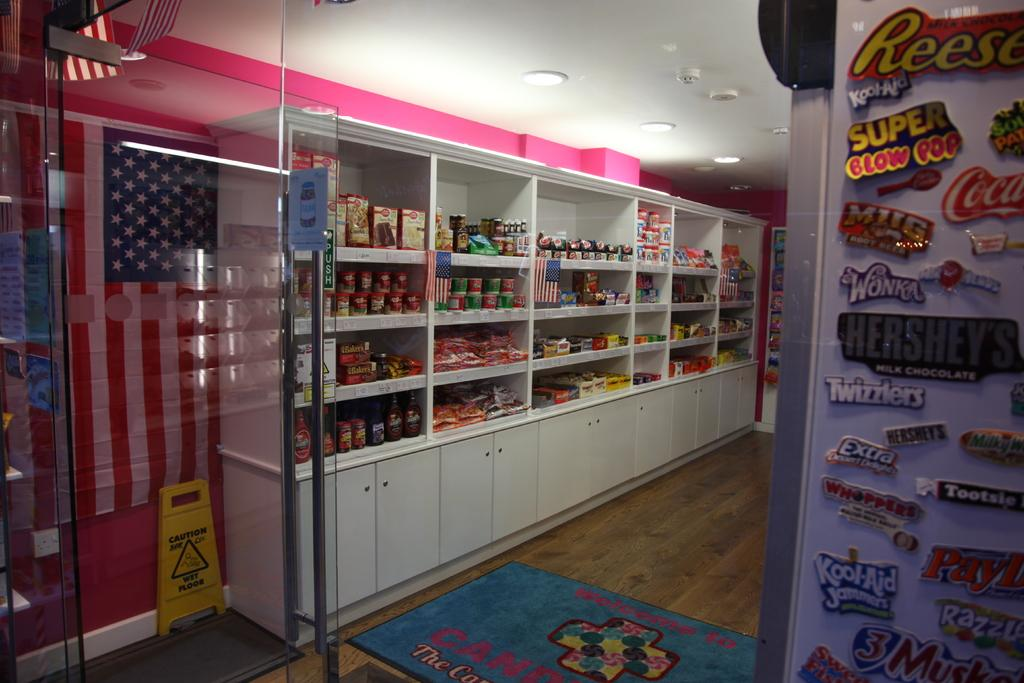<image>
Create a compact narrative representing the image presented. A shop has many magnets on one wall, including one for Super Blow Pops. 